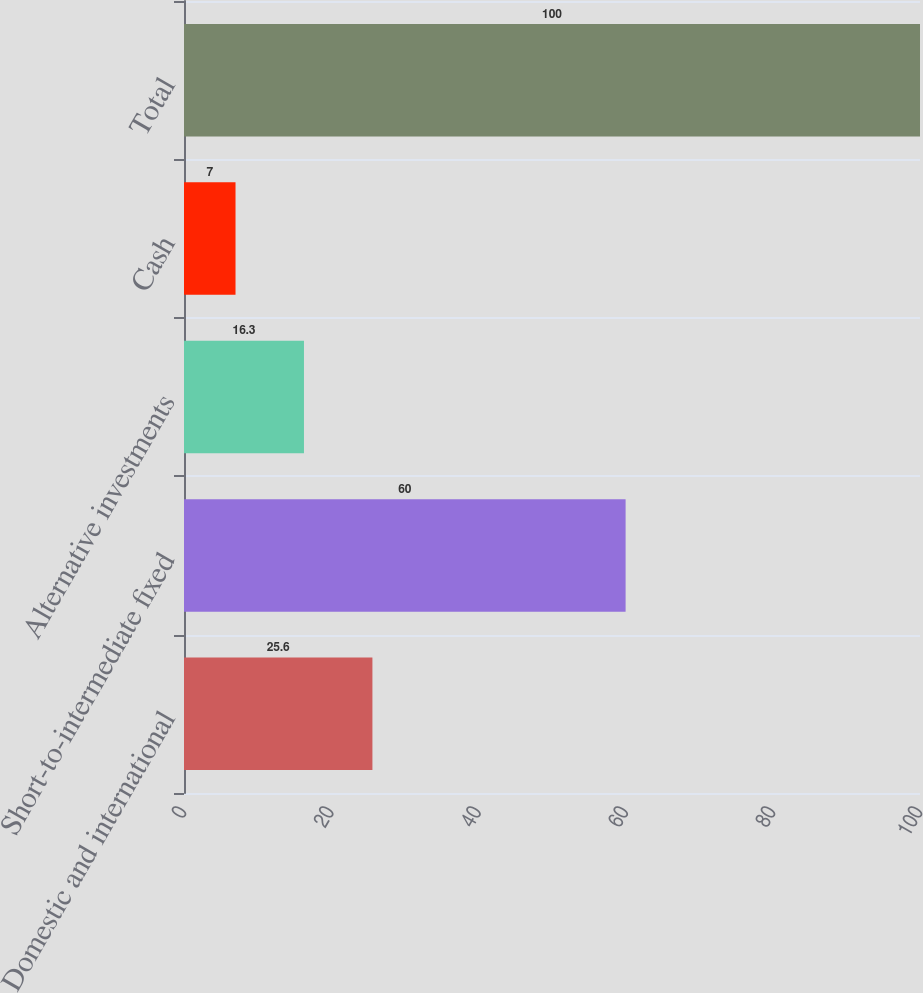<chart> <loc_0><loc_0><loc_500><loc_500><bar_chart><fcel>Domestic and international<fcel>Short-to-intermediate fixed<fcel>Alternative investments<fcel>Cash<fcel>Total<nl><fcel>25.6<fcel>60<fcel>16.3<fcel>7<fcel>100<nl></chart> 